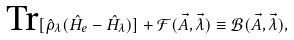Convert formula to latex. <formula><loc_0><loc_0><loc_500><loc_500>\text {Tr} [ \hat { \rho } _ { \lambda } ( \hat { H } _ { e } - \hat { H } _ { \lambda } ) ] + \mathcal { F } ( \vec { A } , \vec { \lambda } ) \equiv \mathcal { B } ( \vec { A } , \vec { \lambda } ) ,</formula> 